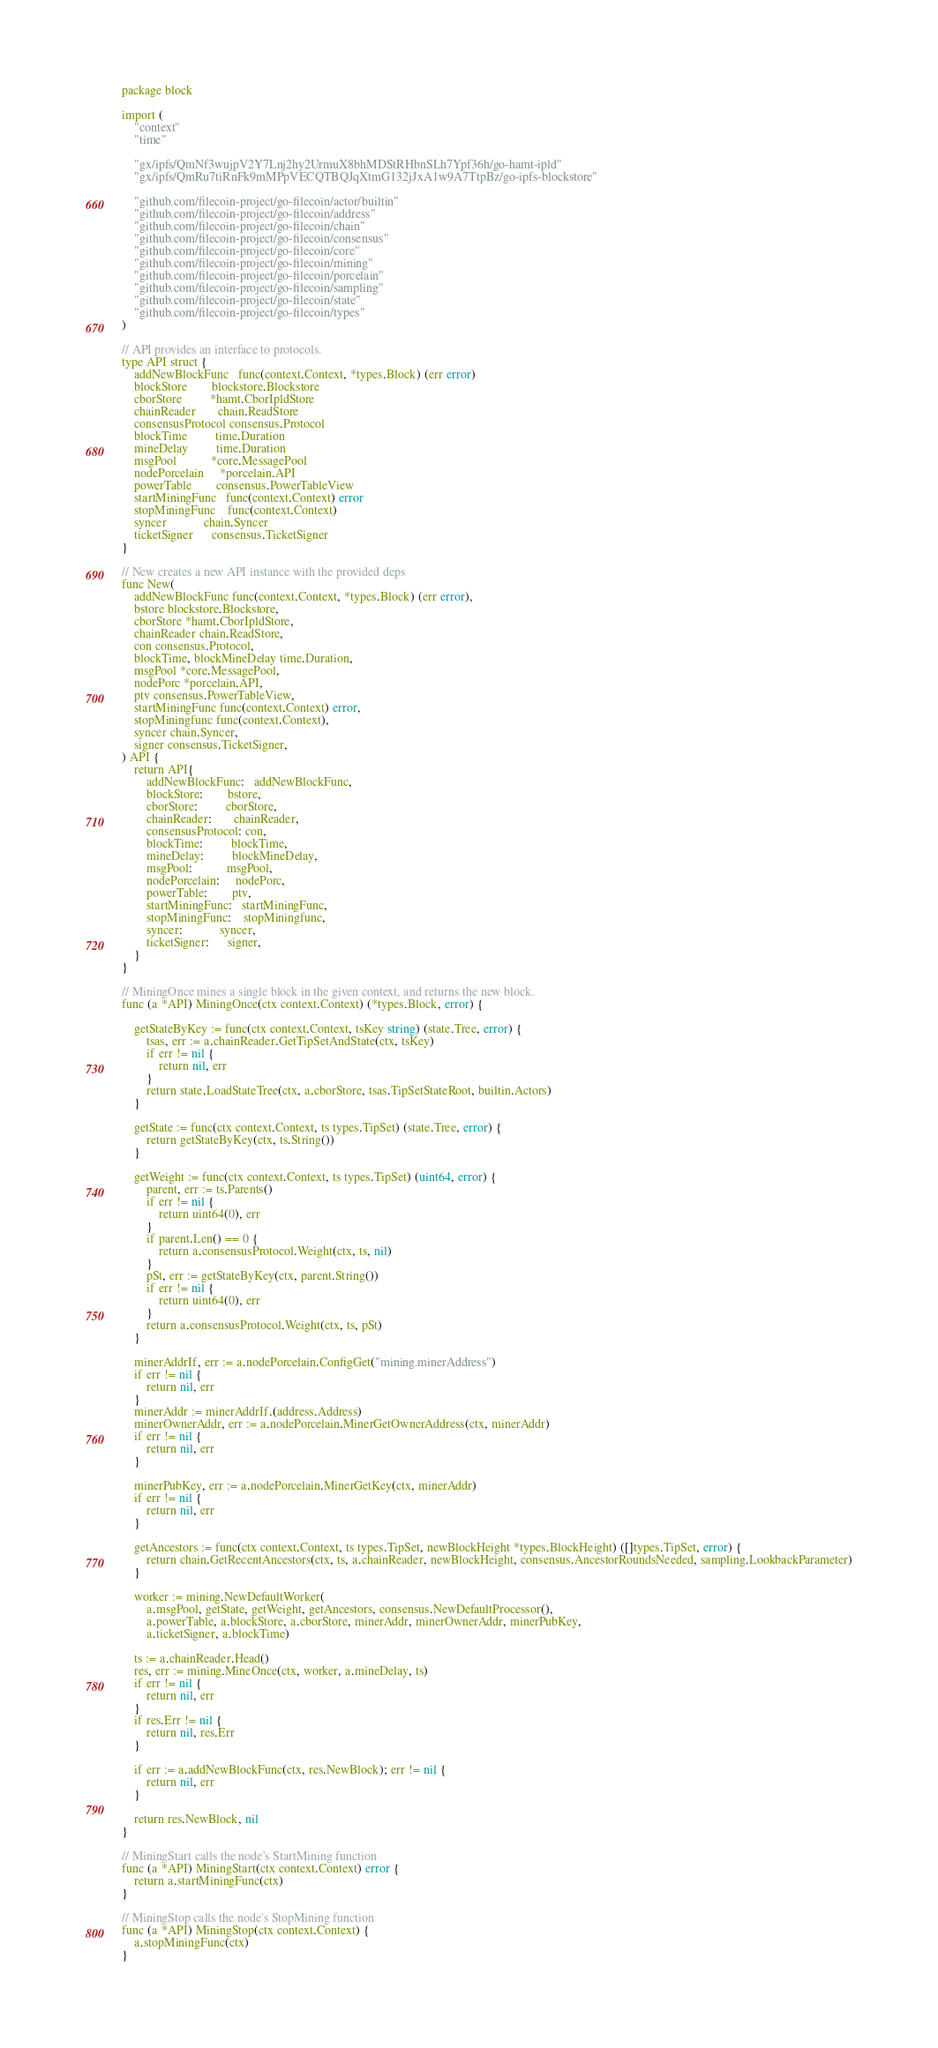Convert code to text. <code><loc_0><loc_0><loc_500><loc_500><_Go_>package block

import (
	"context"
	"time"

	"gx/ipfs/QmNf3wujpV2Y7Lnj2hy2UrmuX8bhMDStRHbnSLh7Ypf36h/go-hamt-ipld"
	"gx/ipfs/QmRu7tiRnFk9mMPpVECQTBQJqXtmG132jJxA1w9A7TtpBz/go-ipfs-blockstore"

	"github.com/filecoin-project/go-filecoin/actor/builtin"
	"github.com/filecoin-project/go-filecoin/address"
	"github.com/filecoin-project/go-filecoin/chain"
	"github.com/filecoin-project/go-filecoin/consensus"
	"github.com/filecoin-project/go-filecoin/core"
	"github.com/filecoin-project/go-filecoin/mining"
	"github.com/filecoin-project/go-filecoin/porcelain"
	"github.com/filecoin-project/go-filecoin/sampling"
	"github.com/filecoin-project/go-filecoin/state"
	"github.com/filecoin-project/go-filecoin/types"
)

// API provides an interface to protocols.
type API struct {
	addNewBlockFunc   func(context.Context, *types.Block) (err error)
	blockStore        blockstore.Blockstore
	cborStore         *hamt.CborIpldStore
	chainReader       chain.ReadStore
	consensusProtocol consensus.Protocol
	blockTime         time.Duration
	mineDelay         time.Duration
	msgPool           *core.MessagePool
	nodePorcelain     *porcelain.API
	powerTable        consensus.PowerTableView
	startMiningFunc   func(context.Context) error
	stopMiningFunc    func(context.Context)
	syncer            chain.Syncer
	ticketSigner      consensus.TicketSigner
}

// New creates a new API instance with the provided deps
func New(
	addNewBlockFunc func(context.Context, *types.Block) (err error),
	bstore blockstore.Blockstore,
	cborStore *hamt.CborIpldStore,
	chainReader chain.ReadStore,
	con consensus.Protocol,
	blockTime, blockMineDelay time.Duration,
	msgPool *core.MessagePool,
	nodePorc *porcelain.API,
	ptv consensus.PowerTableView,
	startMiningFunc func(context.Context) error,
	stopMiningfunc func(context.Context),
	syncer chain.Syncer,
	signer consensus.TicketSigner,
) API {
	return API{
		addNewBlockFunc:   addNewBlockFunc,
		blockStore:        bstore,
		cborStore:         cborStore,
		chainReader:       chainReader,
		consensusProtocol: con,
		blockTime:         blockTime,
		mineDelay:         blockMineDelay,
		msgPool:           msgPool,
		nodePorcelain:     nodePorc,
		powerTable:        ptv,
		startMiningFunc:   startMiningFunc,
		stopMiningFunc:    stopMiningfunc,
		syncer:            syncer,
		ticketSigner:      signer,
	}
}

// MiningOnce mines a single block in the given context, and returns the new block.
func (a *API) MiningOnce(ctx context.Context) (*types.Block, error) {

	getStateByKey := func(ctx context.Context, tsKey string) (state.Tree, error) {
		tsas, err := a.chainReader.GetTipSetAndState(ctx, tsKey)
		if err != nil {
			return nil, err
		}
		return state.LoadStateTree(ctx, a.cborStore, tsas.TipSetStateRoot, builtin.Actors)
	}

	getState := func(ctx context.Context, ts types.TipSet) (state.Tree, error) {
		return getStateByKey(ctx, ts.String())
	}

	getWeight := func(ctx context.Context, ts types.TipSet) (uint64, error) {
		parent, err := ts.Parents()
		if err != nil {
			return uint64(0), err
		}
		if parent.Len() == 0 {
			return a.consensusProtocol.Weight(ctx, ts, nil)
		}
		pSt, err := getStateByKey(ctx, parent.String())
		if err != nil {
			return uint64(0), err
		}
		return a.consensusProtocol.Weight(ctx, ts, pSt)
	}

	minerAddrIf, err := a.nodePorcelain.ConfigGet("mining.minerAddress")
	if err != nil {
		return nil, err
	}
	minerAddr := minerAddrIf.(address.Address)
	minerOwnerAddr, err := a.nodePorcelain.MinerGetOwnerAddress(ctx, minerAddr)
	if err != nil {
		return nil, err
	}

	minerPubKey, err := a.nodePorcelain.MinerGetKey(ctx, minerAddr)
	if err != nil {
		return nil, err
	}

	getAncestors := func(ctx context.Context, ts types.TipSet, newBlockHeight *types.BlockHeight) ([]types.TipSet, error) {
		return chain.GetRecentAncestors(ctx, ts, a.chainReader, newBlockHeight, consensus.AncestorRoundsNeeded, sampling.LookbackParameter)
	}

	worker := mining.NewDefaultWorker(
		a.msgPool, getState, getWeight, getAncestors, consensus.NewDefaultProcessor(),
		a.powerTable, a.blockStore, a.cborStore, minerAddr, minerOwnerAddr, minerPubKey,
		a.ticketSigner, a.blockTime)

	ts := a.chainReader.Head()
	res, err := mining.MineOnce(ctx, worker, a.mineDelay, ts)
	if err != nil {
		return nil, err
	}
	if res.Err != nil {
		return nil, res.Err
	}

	if err := a.addNewBlockFunc(ctx, res.NewBlock); err != nil {
		return nil, err
	}

	return res.NewBlock, nil
}

// MiningStart calls the node's StartMining function
func (a *API) MiningStart(ctx context.Context) error {
	return a.startMiningFunc(ctx)
}

// MiningStop calls the node's StopMining function
func (a *API) MiningStop(ctx context.Context) {
	a.stopMiningFunc(ctx)
}
</code> 